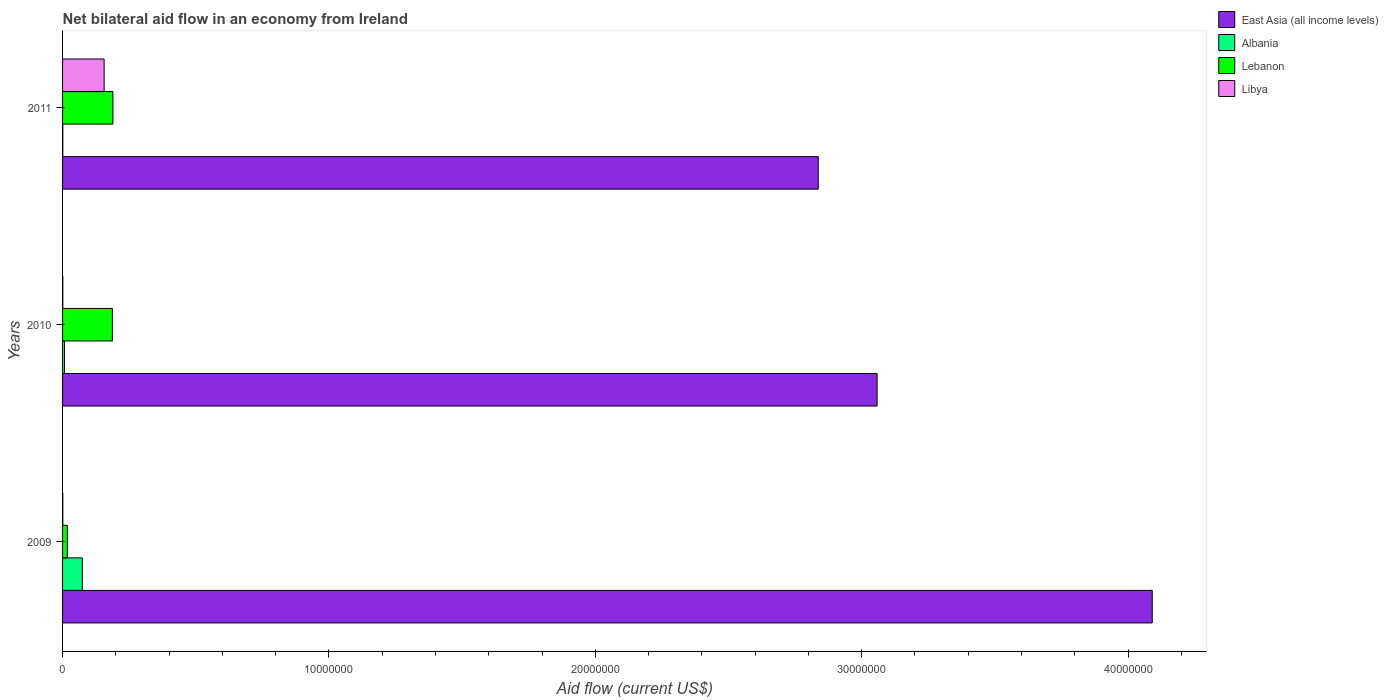Are the number of bars on each tick of the Y-axis equal?
Offer a terse response. Yes. How many bars are there on the 1st tick from the top?
Your response must be concise. 4. How many bars are there on the 1st tick from the bottom?
Your answer should be compact. 4. What is the label of the 2nd group of bars from the top?
Your response must be concise. 2010. What is the net bilateral aid flow in Lebanon in 2010?
Provide a succinct answer. 1.87e+06. Across all years, what is the maximum net bilateral aid flow in Albania?
Offer a very short reply. 7.40e+05. Across all years, what is the minimum net bilateral aid flow in East Asia (all income levels)?
Your answer should be compact. 2.84e+07. What is the total net bilateral aid flow in Albania in the graph?
Make the answer very short. 8.20e+05. What is the difference between the net bilateral aid flow in Libya in 2009 and that in 2011?
Keep it short and to the point. -1.55e+06. What is the difference between the net bilateral aid flow in Albania in 2010 and the net bilateral aid flow in East Asia (all income levels) in 2009?
Your response must be concise. -4.08e+07. What is the average net bilateral aid flow in Libya per year?
Give a very brief answer. 5.27e+05. What is the ratio of the net bilateral aid flow in Albania in 2009 to that in 2010?
Offer a terse response. 10.57. Is the difference between the net bilateral aid flow in Lebanon in 2009 and 2011 greater than the difference between the net bilateral aid flow in Libya in 2009 and 2011?
Your response must be concise. No. What is the difference between the highest and the second highest net bilateral aid flow in Libya?
Give a very brief answer. 1.55e+06. What is the difference between the highest and the lowest net bilateral aid flow in Libya?
Provide a short and direct response. 1.55e+06. In how many years, is the net bilateral aid flow in Lebanon greater than the average net bilateral aid flow in Lebanon taken over all years?
Ensure brevity in your answer.  2. Is it the case that in every year, the sum of the net bilateral aid flow in Libya and net bilateral aid flow in Lebanon is greater than the sum of net bilateral aid flow in East Asia (all income levels) and net bilateral aid flow in Albania?
Your answer should be compact. No. What does the 3rd bar from the top in 2010 represents?
Make the answer very short. Albania. What does the 4th bar from the bottom in 2009 represents?
Ensure brevity in your answer.  Libya. Is it the case that in every year, the sum of the net bilateral aid flow in East Asia (all income levels) and net bilateral aid flow in Libya is greater than the net bilateral aid flow in Lebanon?
Keep it short and to the point. Yes. Are all the bars in the graph horizontal?
Keep it short and to the point. Yes. How many years are there in the graph?
Keep it short and to the point. 3. What is the difference between two consecutive major ticks on the X-axis?
Give a very brief answer. 1.00e+07. Does the graph contain any zero values?
Provide a short and direct response. No. Does the graph contain grids?
Your response must be concise. No. How many legend labels are there?
Offer a very short reply. 4. What is the title of the graph?
Your response must be concise. Net bilateral aid flow in an economy from Ireland. Does "Aruba" appear as one of the legend labels in the graph?
Offer a terse response. No. What is the label or title of the Y-axis?
Your answer should be compact. Years. What is the Aid flow (current US$) of East Asia (all income levels) in 2009?
Your answer should be very brief. 4.09e+07. What is the Aid flow (current US$) in Albania in 2009?
Offer a terse response. 7.40e+05. What is the Aid flow (current US$) in Lebanon in 2009?
Give a very brief answer. 1.80e+05. What is the Aid flow (current US$) of Libya in 2009?
Make the answer very short. 10000. What is the Aid flow (current US$) of East Asia (all income levels) in 2010?
Offer a very short reply. 3.06e+07. What is the Aid flow (current US$) in Lebanon in 2010?
Ensure brevity in your answer.  1.87e+06. What is the Aid flow (current US$) of East Asia (all income levels) in 2011?
Offer a terse response. 2.84e+07. What is the Aid flow (current US$) in Albania in 2011?
Give a very brief answer. 10000. What is the Aid flow (current US$) of Lebanon in 2011?
Make the answer very short. 1.89e+06. What is the Aid flow (current US$) in Libya in 2011?
Provide a short and direct response. 1.56e+06. Across all years, what is the maximum Aid flow (current US$) of East Asia (all income levels)?
Provide a short and direct response. 4.09e+07. Across all years, what is the maximum Aid flow (current US$) in Albania?
Provide a succinct answer. 7.40e+05. Across all years, what is the maximum Aid flow (current US$) in Lebanon?
Offer a terse response. 1.89e+06. Across all years, what is the maximum Aid flow (current US$) of Libya?
Keep it short and to the point. 1.56e+06. Across all years, what is the minimum Aid flow (current US$) of East Asia (all income levels)?
Provide a short and direct response. 2.84e+07. Across all years, what is the minimum Aid flow (current US$) in Libya?
Keep it short and to the point. 10000. What is the total Aid flow (current US$) in East Asia (all income levels) in the graph?
Make the answer very short. 9.99e+07. What is the total Aid flow (current US$) of Albania in the graph?
Make the answer very short. 8.20e+05. What is the total Aid flow (current US$) of Lebanon in the graph?
Provide a short and direct response. 3.94e+06. What is the total Aid flow (current US$) of Libya in the graph?
Offer a terse response. 1.58e+06. What is the difference between the Aid flow (current US$) of East Asia (all income levels) in 2009 and that in 2010?
Offer a terse response. 1.03e+07. What is the difference between the Aid flow (current US$) in Albania in 2009 and that in 2010?
Offer a terse response. 6.70e+05. What is the difference between the Aid flow (current US$) of Lebanon in 2009 and that in 2010?
Your answer should be very brief. -1.69e+06. What is the difference between the Aid flow (current US$) of East Asia (all income levels) in 2009 and that in 2011?
Offer a terse response. 1.25e+07. What is the difference between the Aid flow (current US$) of Albania in 2009 and that in 2011?
Keep it short and to the point. 7.30e+05. What is the difference between the Aid flow (current US$) of Lebanon in 2009 and that in 2011?
Your response must be concise. -1.71e+06. What is the difference between the Aid flow (current US$) in Libya in 2009 and that in 2011?
Give a very brief answer. -1.55e+06. What is the difference between the Aid flow (current US$) of East Asia (all income levels) in 2010 and that in 2011?
Your answer should be very brief. 2.21e+06. What is the difference between the Aid flow (current US$) of Lebanon in 2010 and that in 2011?
Provide a short and direct response. -2.00e+04. What is the difference between the Aid flow (current US$) in Libya in 2010 and that in 2011?
Your response must be concise. -1.55e+06. What is the difference between the Aid flow (current US$) of East Asia (all income levels) in 2009 and the Aid flow (current US$) of Albania in 2010?
Your answer should be very brief. 4.08e+07. What is the difference between the Aid flow (current US$) in East Asia (all income levels) in 2009 and the Aid flow (current US$) in Lebanon in 2010?
Offer a very short reply. 3.90e+07. What is the difference between the Aid flow (current US$) in East Asia (all income levels) in 2009 and the Aid flow (current US$) in Libya in 2010?
Make the answer very short. 4.09e+07. What is the difference between the Aid flow (current US$) of Albania in 2009 and the Aid flow (current US$) of Lebanon in 2010?
Give a very brief answer. -1.13e+06. What is the difference between the Aid flow (current US$) of Albania in 2009 and the Aid flow (current US$) of Libya in 2010?
Make the answer very short. 7.30e+05. What is the difference between the Aid flow (current US$) in East Asia (all income levels) in 2009 and the Aid flow (current US$) in Albania in 2011?
Your response must be concise. 4.09e+07. What is the difference between the Aid flow (current US$) of East Asia (all income levels) in 2009 and the Aid flow (current US$) of Lebanon in 2011?
Your response must be concise. 3.90e+07. What is the difference between the Aid flow (current US$) of East Asia (all income levels) in 2009 and the Aid flow (current US$) of Libya in 2011?
Offer a very short reply. 3.94e+07. What is the difference between the Aid flow (current US$) in Albania in 2009 and the Aid flow (current US$) in Lebanon in 2011?
Make the answer very short. -1.15e+06. What is the difference between the Aid flow (current US$) in Albania in 2009 and the Aid flow (current US$) in Libya in 2011?
Keep it short and to the point. -8.20e+05. What is the difference between the Aid flow (current US$) of Lebanon in 2009 and the Aid flow (current US$) of Libya in 2011?
Offer a terse response. -1.38e+06. What is the difference between the Aid flow (current US$) in East Asia (all income levels) in 2010 and the Aid flow (current US$) in Albania in 2011?
Offer a terse response. 3.06e+07. What is the difference between the Aid flow (current US$) of East Asia (all income levels) in 2010 and the Aid flow (current US$) of Lebanon in 2011?
Make the answer very short. 2.87e+07. What is the difference between the Aid flow (current US$) in East Asia (all income levels) in 2010 and the Aid flow (current US$) in Libya in 2011?
Offer a very short reply. 2.90e+07. What is the difference between the Aid flow (current US$) in Albania in 2010 and the Aid flow (current US$) in Lebanon in 2011?
Ensure brevity in your answer.  -1.82e+06. What is the difference between the Aid flow (current US$) of Albania in 2010 and the Aid flow (current US$) of Libya in 2011?
Your response must be concise. -1.49e+06. What is the average Aid flow (current US$) of East Asia (all income levels) per year?
Provide a succinct answer. 3.33e+07. What is the average Aid flow (current US$) of Albania per year?
Make the answer very short. 2.73e+05. What is the average Aid flow (current US$) in Lebanon per year?
Provide a short and direct response. 1.31e+06. What is the average Aid flow (current US$) of Libya per year?
Offer a very short reply. 5.27e+05. In the year 2009, what is the difference between the Aid flow (current US$) of East Asia (all income levels) and Aid flow (current US$) of Albania?
Provide a succinct answer. 4.02e+07. In the year 2009, what is the difference between the Aid flow (current US$) of East Asia (all income levels) and Aid flow (current US$) of Lebanon?
Your response must be concise. 4.07e+07. In the year 2009, what is the difference between the Aid flow (current US$) of East Asia (all income levels) and Aid flow (current US$) of Libya?
Make the answer very short. 4.09e+07. In the year 2009, what is the difference between the Aid flow (current US$) in Albania and Aid flow (current US$) in Lebanon?
Keep it short and to the point. 5.60e+05. In the year 2009, what is the difference between the Aid flow (current US$) of Albania and Aid flow (current US$) of Libya?
Your answer should be compact. 7.30e+05. In the year 2010, what is the difference between the Aid flow (current US$) of East Asia (all income levels) and Aid flow (current US$) of Albania?
Ensure brevity in your answer.  3.05e+07. In the year 2010, what is the difference between the Aid flow (current US$) in East Asia (all income levels) and Aid flow (current US$) in Lebanon?
Make the answer very short. 2.87e+07. In the year 2010, what is the difference between the Aid flow (current US$) of East Asia (all income levels) and Aid flow (current US$) of Libya?
Provide a short and direct response. 3.06e+07. In the year 2010, what is the difference between the Aid flow (current US$) in Albania and Aid flow (current US$) in Lebanon?
Ensure brevity in your answer.  -1.80e+06. In the year 2010, what is the difference between the Aid flow (current US$) in Lebanon and Aid flow (current US$) in Libya?
Your response must be concise. 1.86e+06. In the year 2011, what is the difference between the Aid flow (current US$) of East Asia (all income levels) and Aid flow (current US$) of Albania?
Your answer should be compact. 2.84e+07. In the year 2011, what is the difference between the Aid flow (current US$) in East Asia (all income levels) and Aid flow (current US$) in Lebanon?
Provide a succinct answer. 2.65e+07. In the year 2011, what is the difference between the Aid flow (current US$) of East Asia (all income levels) and Aid flow (current US$) of Libya?
Your answer should be compact. 2.68e+07. In the year 2011, what is the difference between the Aid flow (current US$) of Albania and Aid flow (current US$) of Lebanon?
Give a very brief answer. -1.88e+06. In the year 2011, what is the difference between the Aid flow (current US$) in Albania and Aid flow (current US$) in Libya?
Your answer should be very brief. -1.55e+06. In the year 2011, what is the difference between the Aid flow (current US$) of Lebanon and Aid flow (current US$) of Libya?
Provide a short and direct response. 3.30e+05. What is the ratio of the Aid flow (current US$) in East Asia (all income levels) in 2009 to that in 2010?
Make the answer very short. 1.34. What is the ratio of the Aid flow (current US$) of Albania in 2009 to that in 2010?
Keep it short and to the point. 10.57. What is the ratio of the Aid flow (current US$) of Lebanon in 2009 to that in 2010?
Make the answer very short. 0.1. What is the ratio of the Aid flow (current US$) in Libya in 2009 to that in 2010?
Keep it short and to the point. 1. What is the ratio of the Aid flow (current US$) of East Asia (all income levels) in 2009 to that in 2011?
Offer a very short reply. 1.44. What is the ratio of the Aid flow (current US$) of Lebanon in 2009 to that in 2011?
Provide a succinct answer. 0.1. What is the ratio of the Aid flow (current US$) of Libya in 2009 to that in 2011?
Provide a succinct answer. 0.01. What is the ratio of the Aid flow (current US$) of East Asia (all income levels) in 2010 to that in 2011?
Provide a short and direct response. 1.08. What is the ratio of the Aid flow (current US$) in Libya in 2010 to that in 2011?
Your response must be concise. 0.01. What is the difference between the highest and the second highest Aid flow (current US$) in East Asia (all income levels)?
Offer a terse response. 1.03e+07. What is the difference between the highest and the second highest Aid flow (current US$) of Albania?
Provide a short and direct response. 6.70e+05. What is the difference between the highest and the second highest Aid flow (current US$) of Libya?
Your response must be concise. 1.55e+06. What is the difference between the highest and the lowest Aid flow (current US$) of East Asia (all income levels)?
Make the answer very short. 1.25e+07. What is the difference between the highest and the lowest Aid flow (current US$) in Albania?
Your answer should be compact. 7.30e+05. What is the difference between the highest and the lowest Aid flow (current US$) in Lebanon?
Give a very brief answer. 1.71e+06. What is the difference between the highest and the lowest Aid flow (current US$) of Libya?
Ensure brevity in your answer.  1.55e+06. 